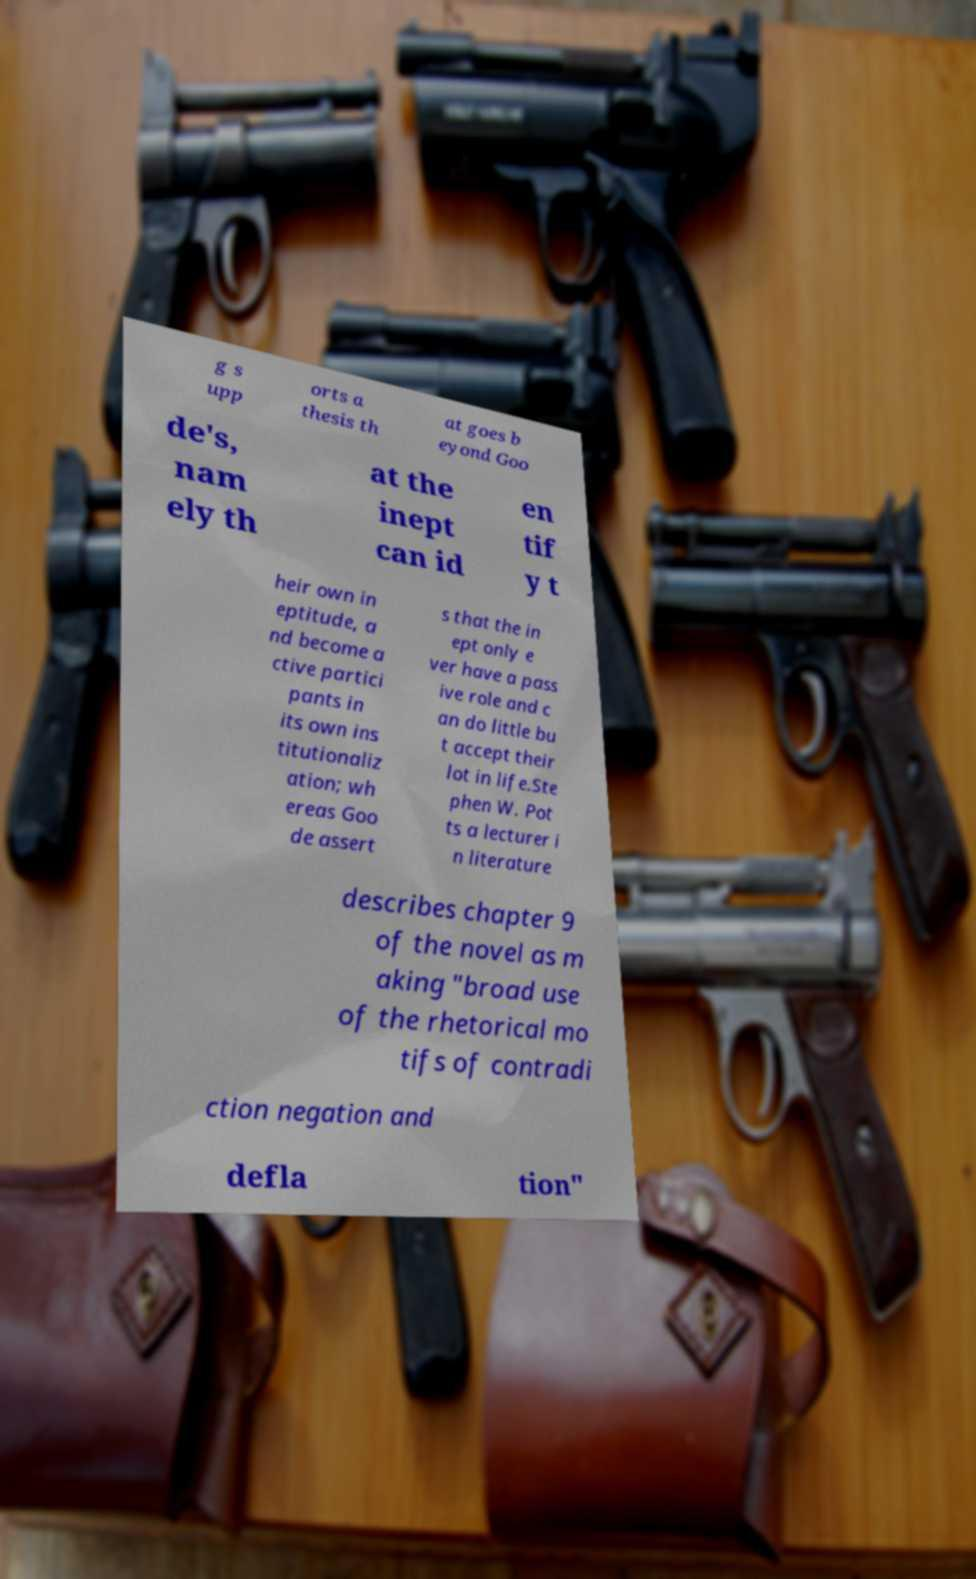Please identify and transcribe the text found in this image. g s upp orts a thesis th at goes b eyond Goo de's, nam ely th at the inept can id en tif y t heir own in eptitude, a nd become a ctive partici pants in its own ins titutionaliz ation; wh ereas Goo de assert s that the in ept only e ver have a pass ive role and c an do little bu t accept their lot in life.Ste phen W. Pot ts a lecturer i n literature describes chapter 9 of the novel as m aking "broad use of the rhetorical mo tifs of contradi ction negation and defla tion" 